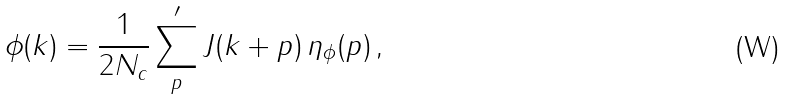Convert formula to latex. <formula><loc_0><loc_0><loc_500><loc_500>\phi ( { k } ) = \frac { 1 } { 2 N _ { c } } \sum _ { p } ^ { \prime } J ( { k + p } ) \, \eta _ { \phi } ( { p } ) \, ,</formula> 